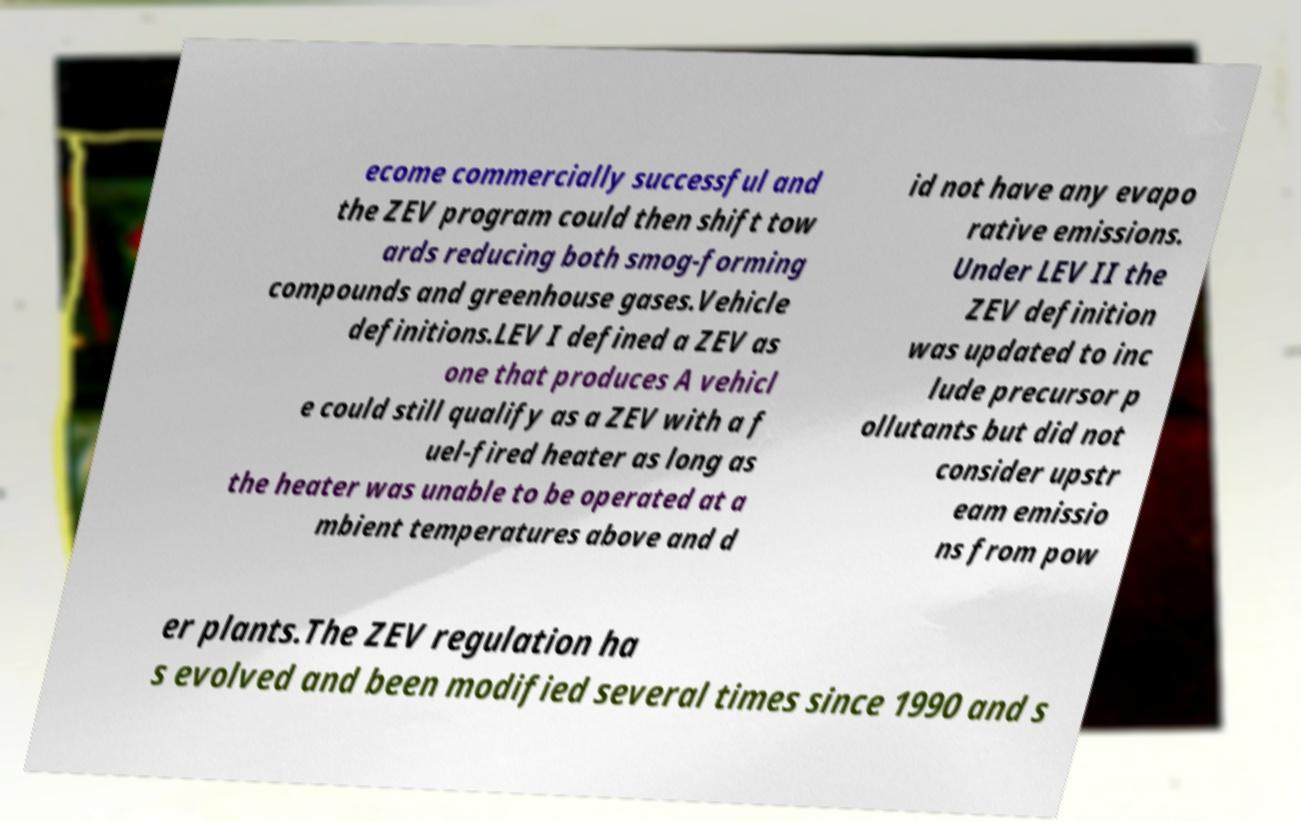Could you assist in decoding the text presented in this image and type it out clearly? ecome commercially successful and the ZEV program could then shift tow ards reducing both smog-forming compounds and greenhouse gases.Vehicle definitions.LEV I defined a ZEV as one that produces A vehicl e could still qualify as a ZEV with a f uel-fired heater as long as the heater was unable to be operated at a mbient temperatures above and d id not have any evapo rative emissions. Under LEV II the ZEV definition was updated to inc lude precursor p ollutants but did not consider upstr eam emissio ns from pow er plants.The ZEV regulation ha s evolved and been modified several times since 1990 and s 